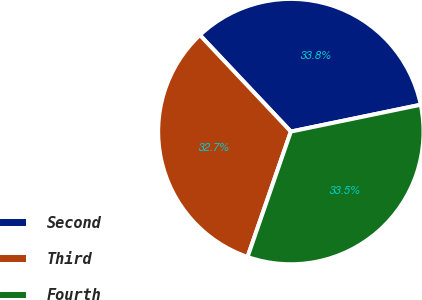<chart> <loc_0><loc_0><loc_500><loc_500><pie_chart><fcel>Second<fcel>Third<fcel>Fourth<nl><fcel>33.79%<fcel>32.68%<fcel>33.54%<nl></chart> 